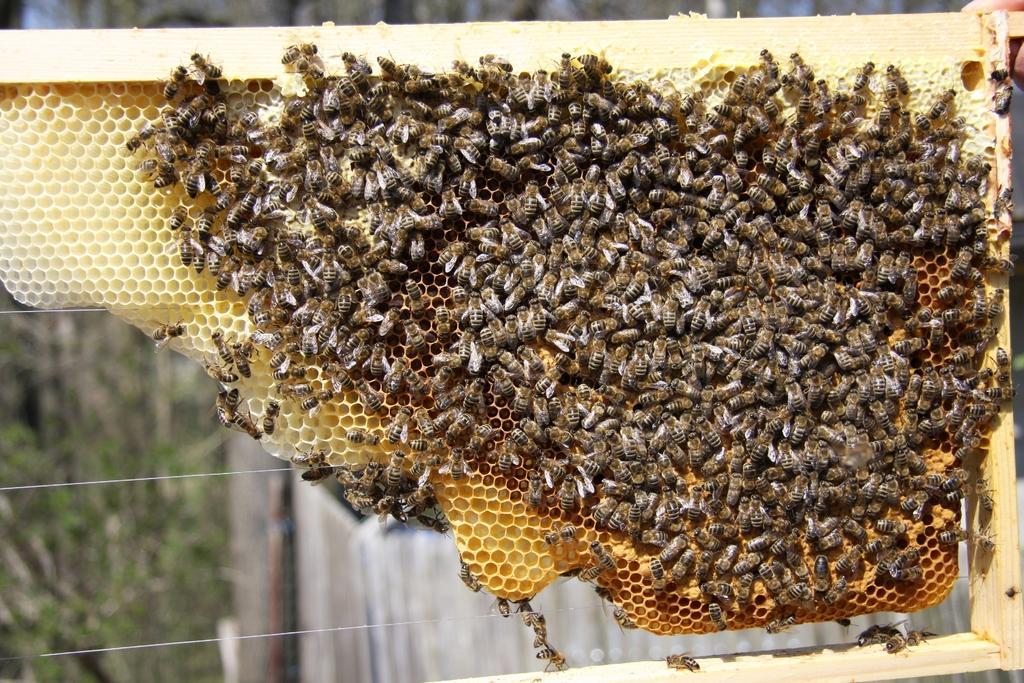Could you give a brief overview of what you see in this image? In this image there are honey bees on the honeycomb , and at the background there are wires, plants. 